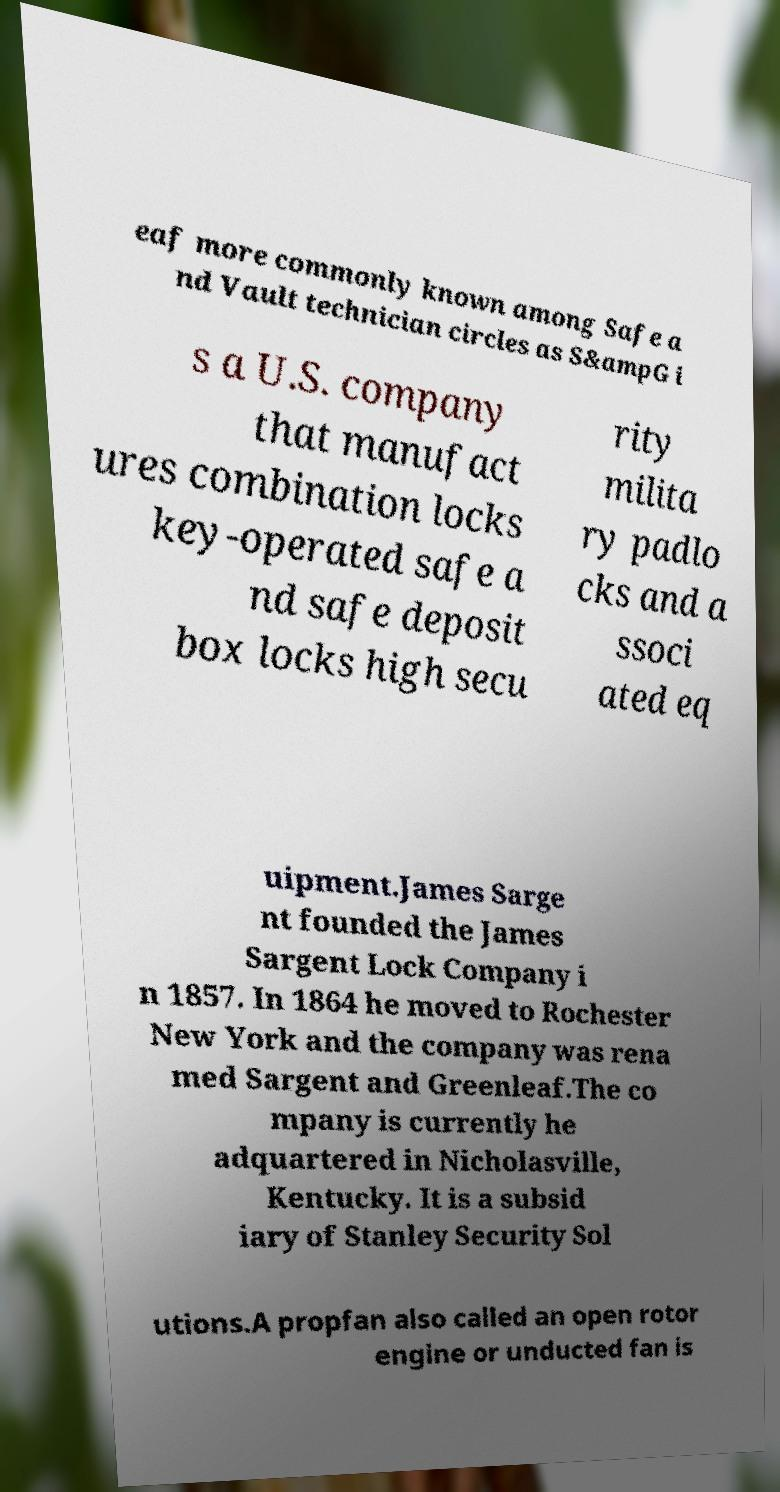Can you read and provide the text displayed in the image?This photo seems to have some interesting text. Can you extract and type it out for me? eaf more commonly known among Safe a nd Vault technician circles as S&ampG i s a U.S. company that manufact ures combination locks key-operated safe a nd safe deposit box locks high secu rity milita ry padlo cks and a ssoci ated eq uipment.James Sarge nt founded the James Sargent Lock Company i n 1857. In 1864 he moved to Rochester New York and the company was rena med Sargent and Greenleaf.The co mpany is currently he adquartered in Nicholasville, Kentucky. It is a subsid iary of Stanley Security Sol utions.A propfan also called an open rotor engine or unducted fan is 